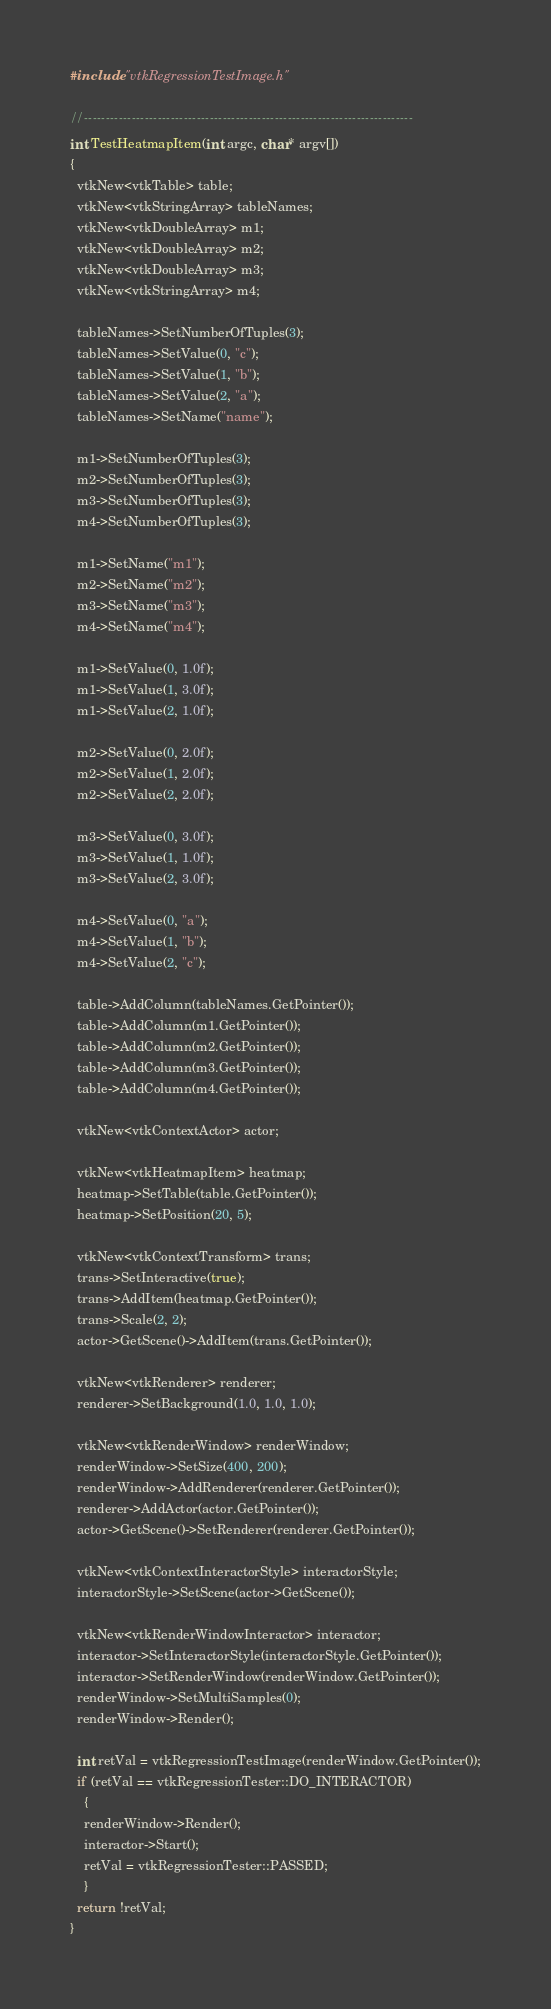Convert code to text. <code><loc_0><loc_0><loc_500><loc_500><_C++_>
#include "vtkRegressionTestImage.h"

//----------------------------------------------------------------------------
int TestHeatmapItem(int argc, char* argv[])
{
  vtkNew<vtkTable> table;
  vtkNew<vtkStringArray> tableNames;
  vtkNew<vtkDoubleArray> m1;
  vtkNew<vtkDoubleArray> m2;
  vtkNew<vtkDoubleArray> m3;
  vtkNew<vtkStringArray> m4;

  tableNames->SetNumberOfTuples(3);
  tableNames->SetValue(0, "c");
  tableNames->SetValue(1, "b");
  tableNames->SetValue(2, "a");
  tableNames->SetName("name");

  m1->SetNumberOfTuples(3);
  m2->SetNumberOfTuples(3);
  m3->SetNumberOfTuples(3);
  m4->SetNumberOfTuples(3);

  m1->SetName("m1");
  m2->SetName("m2");
  m3->SetName("m3");
  m4->SetName("m4");

  m1->SetValue(0, 1.0f);
  m1->SetValue(1, 3.0f);
  m1->SetValue(2, 1.0f);

  m2->SetValue(0, 2.0f);
  m2->SetValue(1, 2.0f);
  m2->SetValue(2, 2.0f);

  m3->SetValue(0, 3.0f);
  m3->SetValue(1, 1.0f);
  m3->SetValue(2, 3.0f);

  m4->SetValue(0, "a");
  m4->SetValue(1, "b");
  m4->SetValue(2, "c");

  table->AddColumn(tableNames.GetPointer());
  table->AddColumn(m1.GetPointer());
  table->AddColumn(m2.GetPointer());
  table->AddColumn(m3.GetPointer());
  table->AddColumn(m4.GetPointer());

  vtkNew<vtkContextActor> actor;

  vtkNew<vtkHeatmapItem> heatmap;
  heatmap->SetTable(table.GetPointer());
  heatmap->SetPosition(20, 5);

  vtkNew<vtkContextTransform> trans;
  trans->SetInteractive(true);
  trans->AddItem(heatmap.GetPointer());
  trans->Scale(2, 2);
  actor->GetScene()->AddItem(trans.GetPointer());

  vtkNew<vtkRenderer> renderer;
  renderer->SetBackground(1.0, 1.0, 1.0);

  vtkNew<vtkRenderWindow> renderWindow;
  renderWindow->SetSize(400, 200);
  renderWindow->AddRenderer(renderer.GetPointer());
  renderer->AddActor(actor.GetPointer());
  actor->GetScene()->SetRenderer(renderer.GetPointer());

  vtkNew<vtkContextInteractorStyle> interactorStyle;
  interactorStyle->SetScene(actor->GetScene());

  vtkNew<vtkRenderWindowInteractor> interactor;
  interactor->SetInteractorStyle(interactorStyle.GetPointer());
  interactor->SetRenderWindow(renderWindow.GetPointer());
  renderWindow->SetMultiSamples(0);
  renderWindow->Render();

  int retVal = vtkRegressionTestImage(renderWindow.GetPointer());
  if (retVal == vtkRegressionTester::DO_INTERACTOR)
    {
    renderWindow->Render();
    interactor->Start();
    retVal = vtkRegressionTester::PASSED;
    }
  return !retVal;
}
</code> 